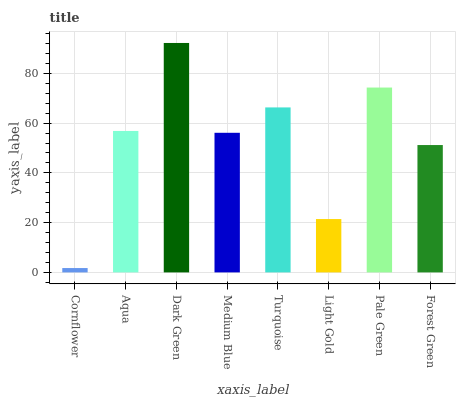Is Cornflower the minimum?
Answer yes or no. Yes. Is Dark Green the maximum?
Answer yes or no. Yes. Is Aqua the minimum?
Answer yes or no. No. Is Aqua the maximum?
Answer yes or no. No. Is Aqua greater than Cornflower?
Answer yes or no. Yes. Is Cornflower less than Aqua?
Answer yes or no. Yes. Is Cornflower greater than Aqua?
Answer yes or no. No. Is Aqua less than Cornflower?
Answer yes or no. No. Is Aqua the high median?
Answer yes or no. Yes. Is Medium Blue the low median?
Answer yes or no. Yes. Is Dark Green the high median?
Answer yes or no. No. Is Pale Green the low median?
Answer yes or no. No. 